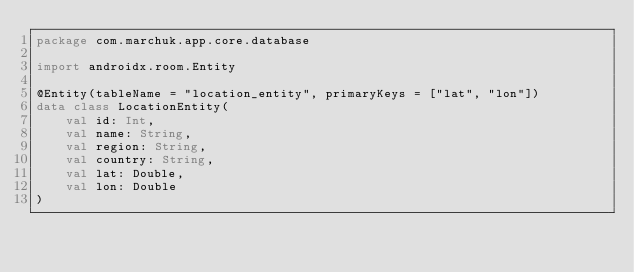Convert code to text. <code><loc_0><loc_0><loc_500><loc_500><_Kotlin_>package com.marchuk.app.core.database

import androidx.room.Entity

@Entity(tableName = "location_entity", primaryKeys = ["lat", "lon"])
data class LocationEntity(
    val id: Int,
    val name: String,
    val region: String,
    val country: String,
    val lat: Double,
    val lon: Double
)</code> 